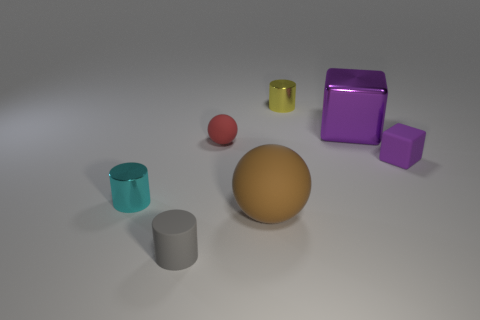Subtract all brown spheres. How many spheres are left? 1 Subtract all yellow shiny cylinders. How many cylinders are left? 2 Subtract 1 cylinders. How many cylinders are left? 2 Subtract all cylinders. How many objects are left? 4 Subtract all red spheres. How many gray cylinders are left? 1 Add 2 balls. How many objects exist? 9 Add 4 big gray rubber blocks. How many big gray rubber blocks exist? 4 Subtract 0 purple spheres. How many objects are left? 7 Subtract all cyan blocks. Subtract all cyan cylinders. How many blocks are left? 2 Subtract all yellow things. Subtract all purple blocks. How many objects are left? 4 